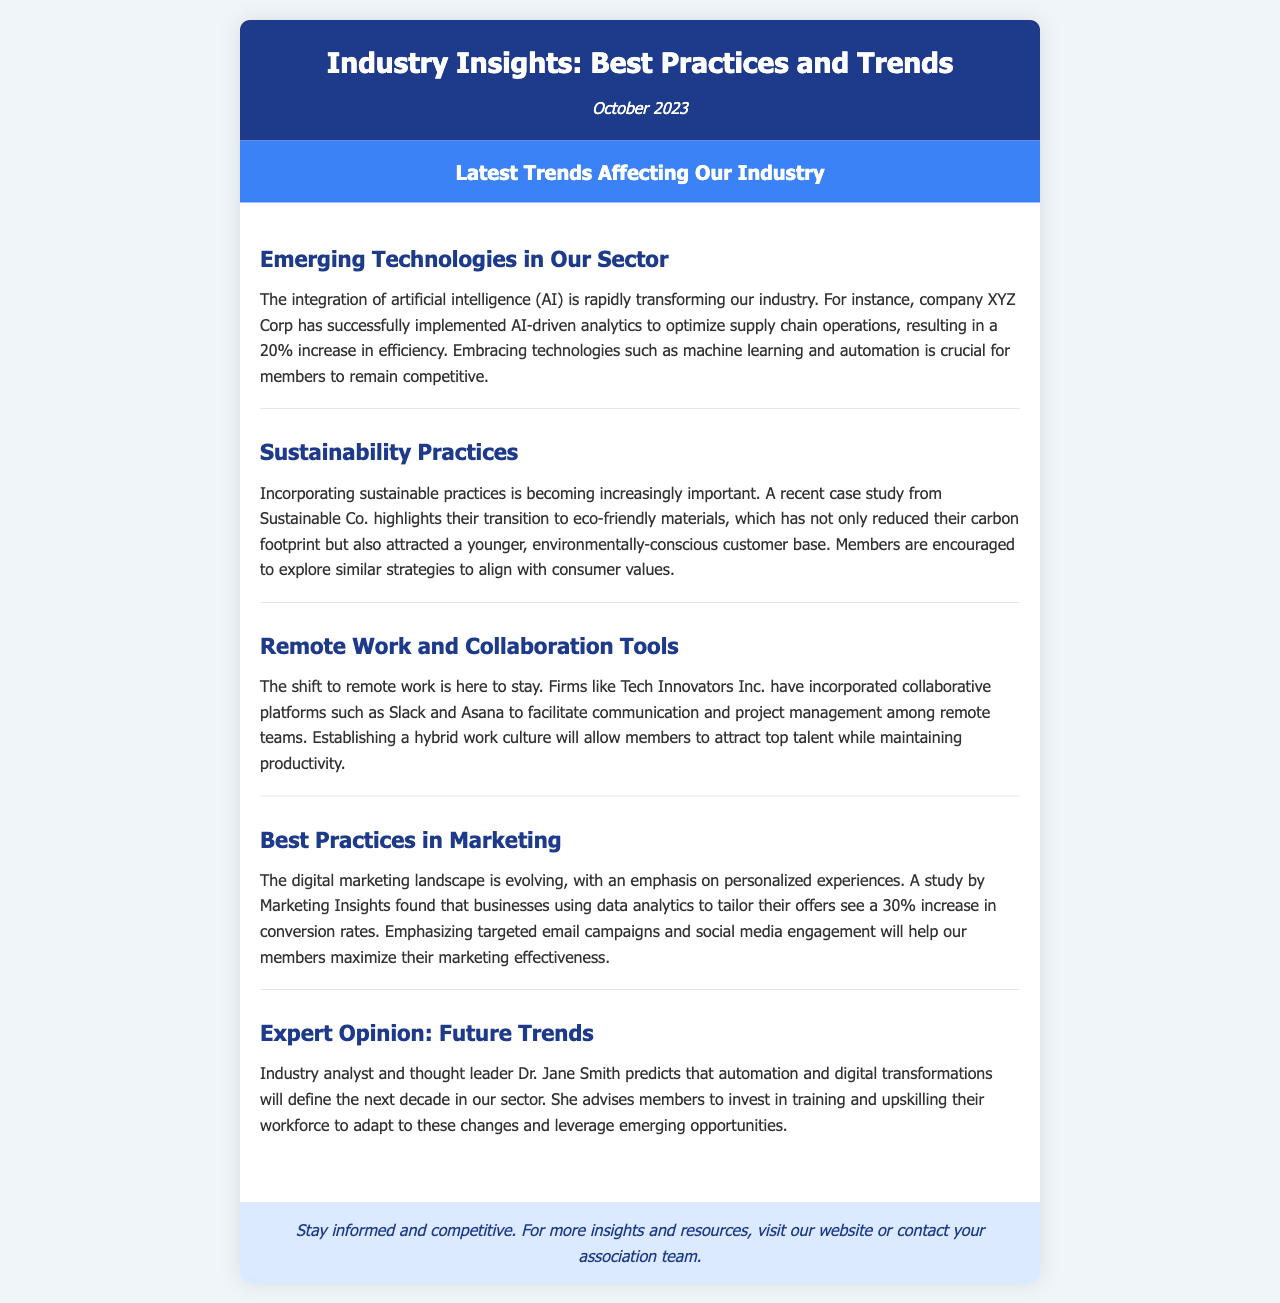What company successfully implemented AI-driven analytics? The document states that company XYZ Corp successfully implemented AI-driven analytics.
Answer: XYZ Corp What increase in efficiency did XYZ Corp achieve? The document mentions a 20% increase in efficiency resulting from AI-driven analytics implementation.
Answer: 20% What is a recent case study mentioned in relation to sustainability? The document highlights a case study from Sustainable Co. regarding their transition to eco-friendly materials.
Answer: Sustainable Co What marketing tactic resulted in a 30% increase in conversion rates? The document states that using data analytics to tailor offers results in a 30% increase in conversion rates.
Answer: Data analytics Who predicts that automation will define the next decade in the industry? The document names Dr. Jane Smith as the industry analyst who predicts automation and digital transformations will shape the next decade.
Answer: Dr. Jane Smith What are some collaboration tools mentioned? The document mentions Slack and Asana as collaboration tools used by Tech Innovators Inc.
Answer: Slack and Asana What is the main focus of the newsletter? The newsletter focuses on providing insights into best practices and trends affecting the industry.
Answer: Best practices and trends 